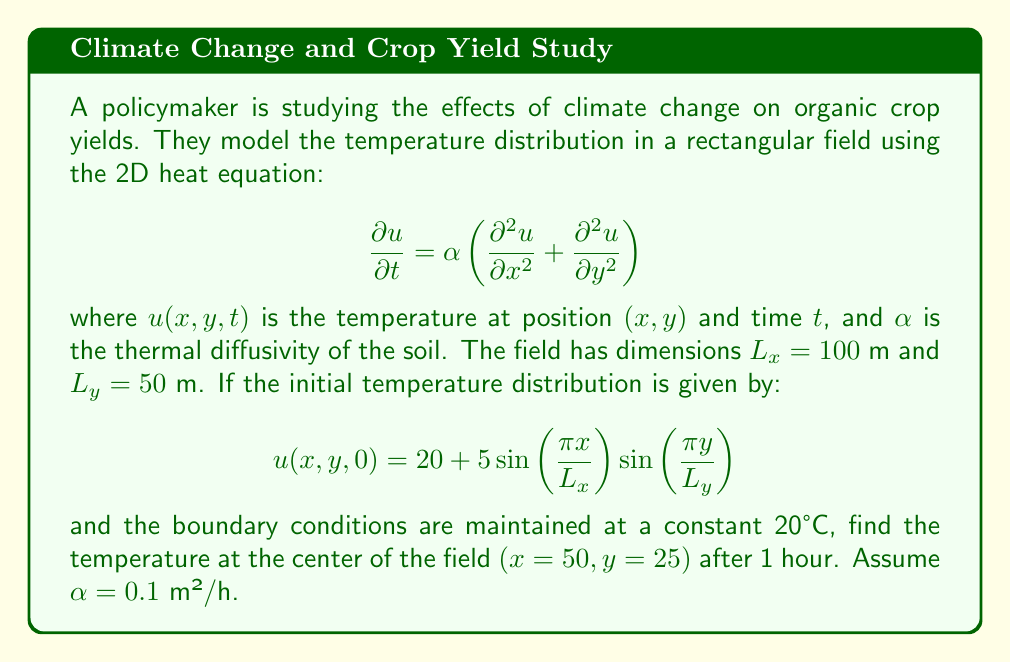Can you answer this question? To solve this problem, we need to use the separation of variables method for the 2D heat equation with the given initial and boundary conditions.

1) The general solution for the 2D heat equation with these boundary conditions is:

   $$u(x,y,t) = 20 + \sum_{m=1}^{\infty}\sum_{n=1}^{\infty} A_{mn} \sin\left(\frac{m\pi x}{L_x}\right)\sin\left(\frac{n\pi y}{L_y}\right)e^{-\alpha(\frac{m^2\pi^2}{L_x^2}+\frac{n^2\pi^2}{L_y^2})t}$$

2) Comparing this with the initial condition, we see that only the term with $m=1$ and $n=1$ is non-zero, with $A_{11} = 5$.

3) Therefore, our solution simplifies to:

   $$u(x,y,t) = 20 + 5\sin\left(\frac{\pi x}{L_x}\right)\sin\left(\frac{\pi y}{L_y}\right)e^{-\alpha(\frac{\pi^2}{L_x^2}+\frac{\pi^2}{L_y^2})t}$$

4) Now, we need to evaluate this at the center of the field $(x=50, y=25)$ after 1 hour $(t=1)$:

   $$u(50,25,1) = 20 + 5\sin\left(\frac{\pi \cdot 50}{100}\right)\sin\left(\frac{\pi \cdot 25}{50}\right)e^{-0.1(\frac{\pi^2}{100^2}+\frac{\pi^2}{50^2}) \cdot 1}$$

5) Simplify:
   
   $$u(50,25,1) = 20 + 5\sin\left(\frac{\pi}{2}\right)\sin\left(\frac{\pi}{2}\right)e^{-0.1\pi^2(\frac{1}{10000}+\frac{1}{2500})}$$

6) Calculate:
   
   $$u(50,25,1) = 20 + 5 \cdot 1 \cdot 1 \cdot e^{-0.1\pi^2(0.0001+0.0004)}$$
   $$u(50,25,1) = 20 + 5e^{-0.00015708}$$
   $$u(50,25,1) \approx 24.9992$$

Therefore, the temperature at the center of the field after 1 hour is approximately 24.9992°C.
Answer: 24.9992°C 